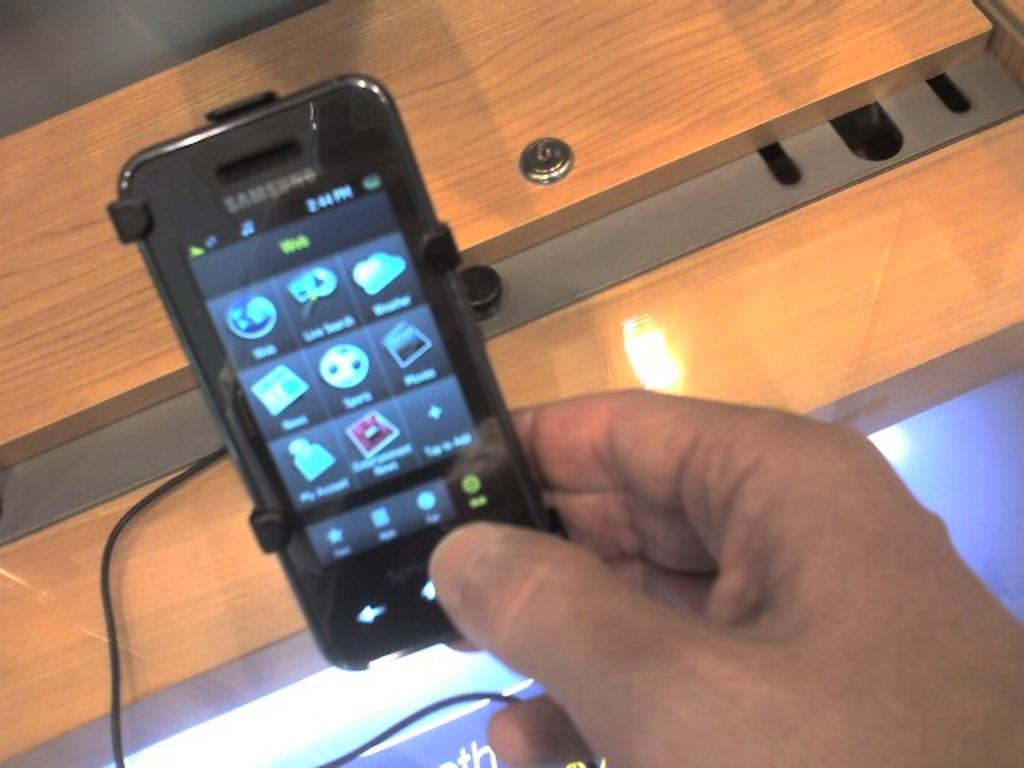<image>
Share a concise interpretation of the image provided. A hand holding a small cell phone with th samsung brand at the top of the device. 